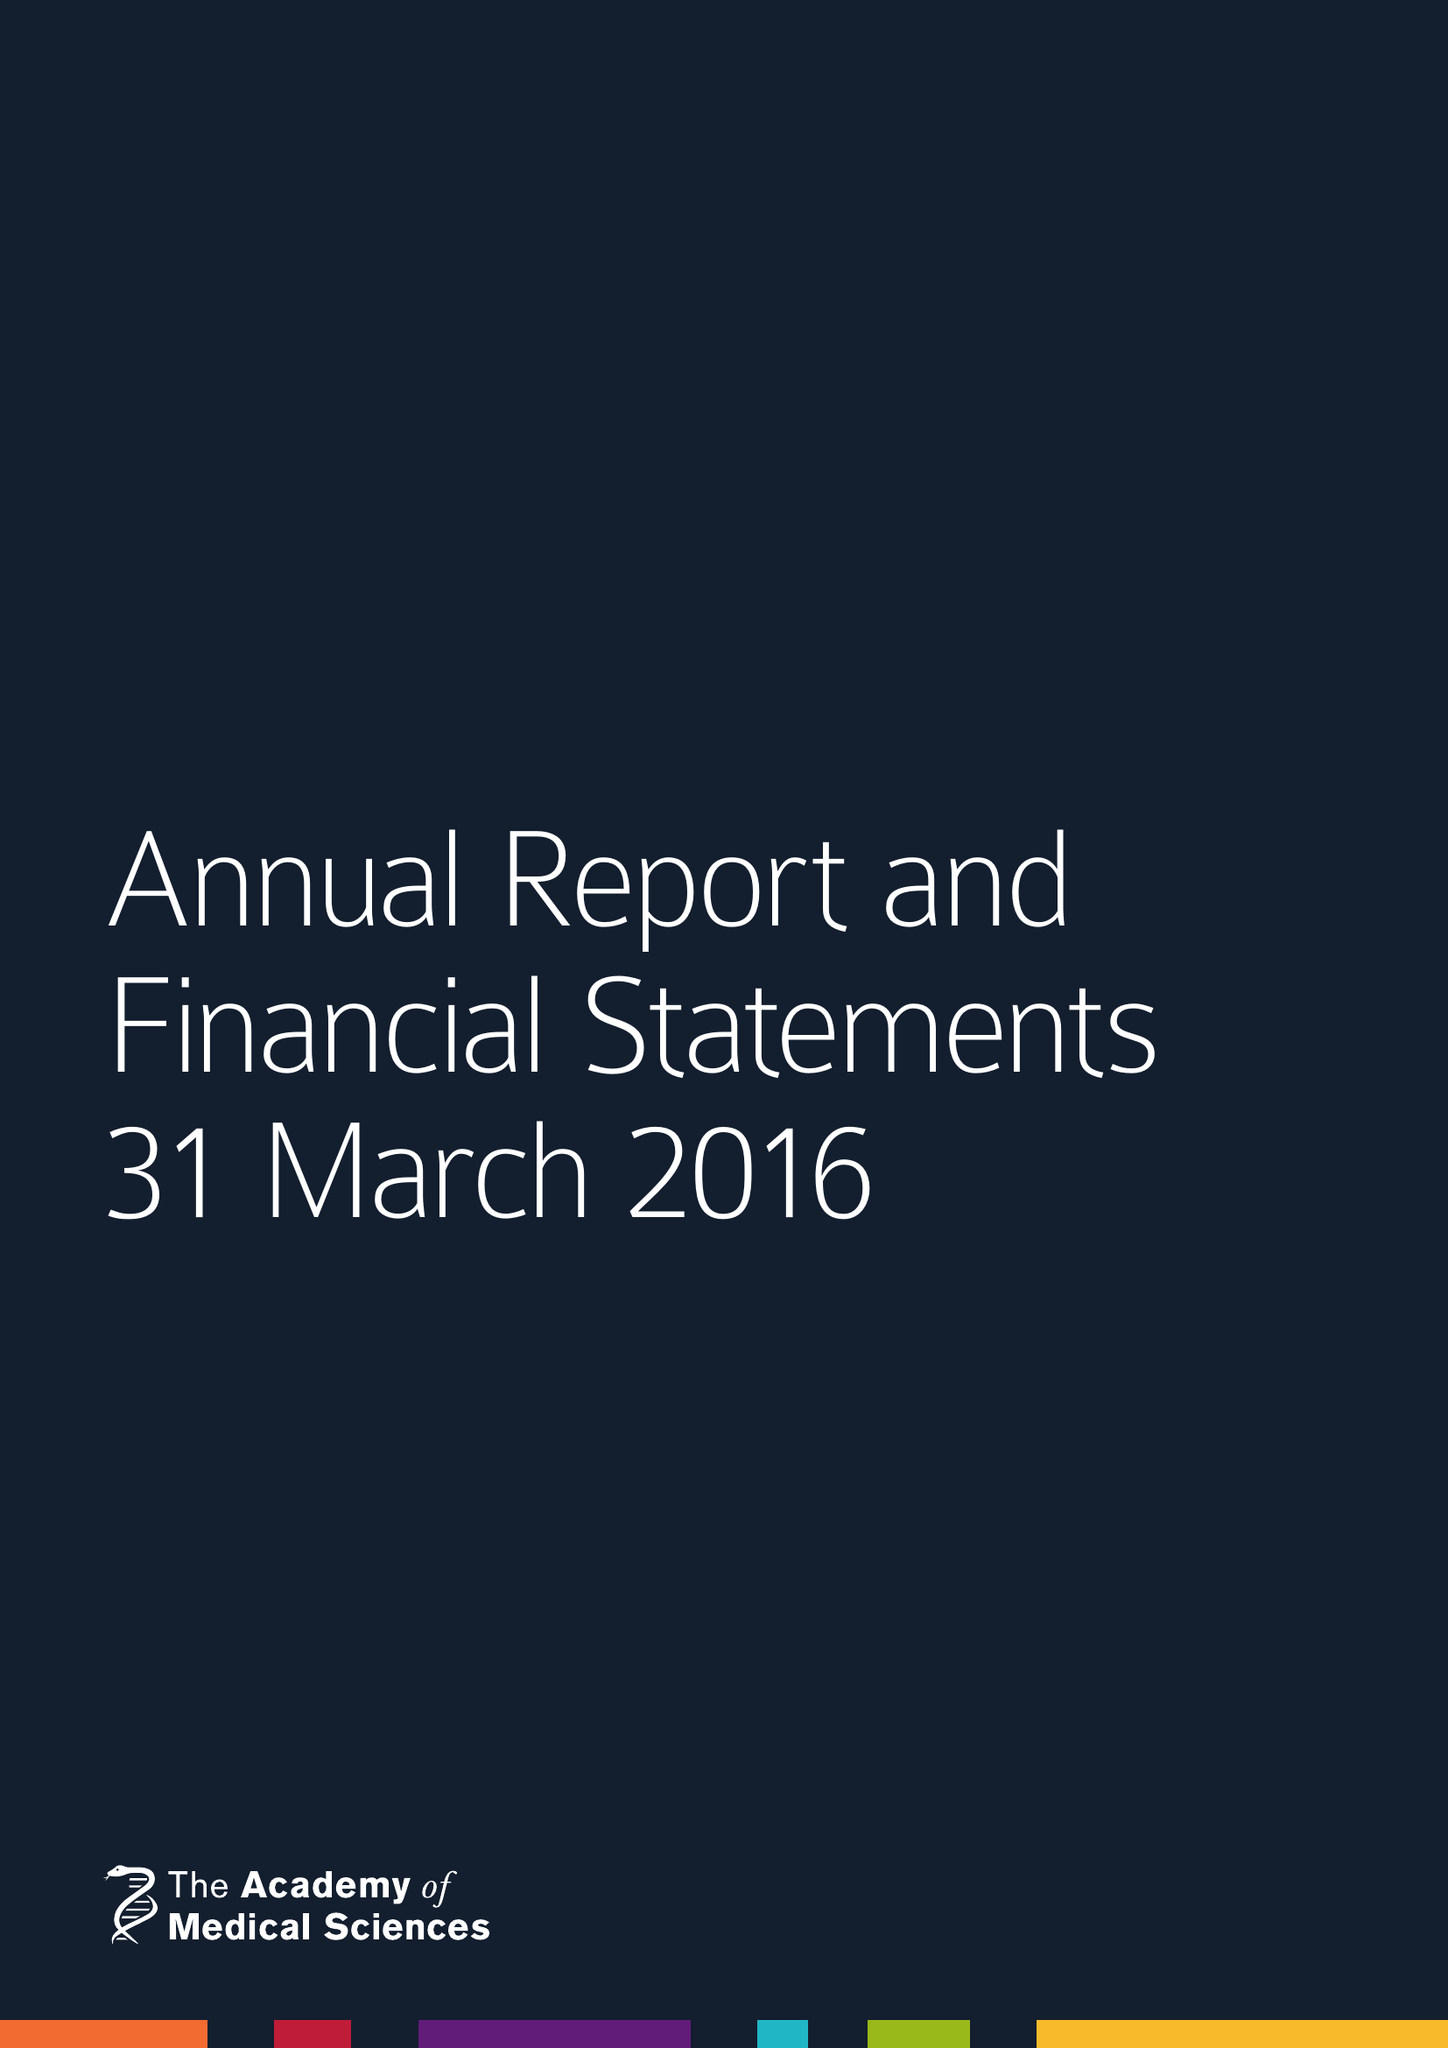What is the value for the address__street_line?
Answer the question using a single word or phrase. 41 PORTLAND PLACE 